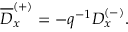Convert formula to latex. <formula><loc_0><loc_0><loc_500><loc_500>\overline { D } _ { x } ^ { ( + ) } = - q ^ { - 1 } D _ { x } ^ { ( - ) } .</formula> 